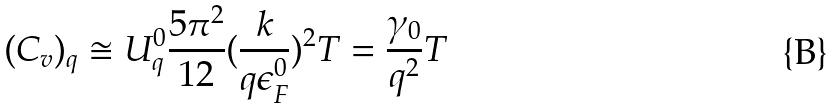<formula> <loc_0><loc_0><loc_500><loc_500>( C _ { v } ) _ { q } \cong U _ { q } ^ { 0 } \frac { 5 \pi ^ { 2 } } { 1 2 } ( \frac { k } { q \epsilon _ { F } ^ { 0 } } ) ^ { 2 } T = \frac { \gamma _ { 0 } } { q ^ { 2 } } T</formula> 